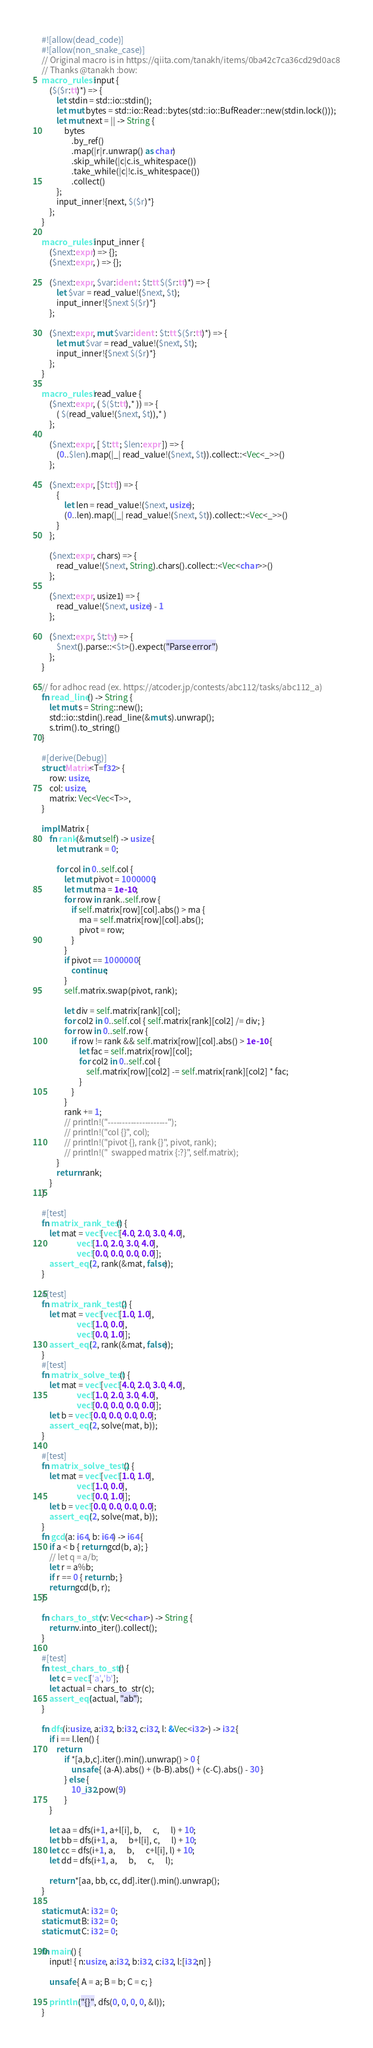Convert code to text. <code><loc_0><loc_0><loc_500><loc_500><_Rust_>#![allow(dead_code)]
#![allow(non_snake_case)]
// Original macro is in https://qiita.com/tanakh/items/0ba42c7ca36cd29d0ac8
// Thanks @tanakh :bow:
macro_rules! input {
    ($($r:tt)*) => {
        let stdin = std::io::stdin();
        let mut bytes = std::io::Read::bytes(std::io::BufReader::new(stdin.lock()));
        let mut next = || -> String {
            bytes
                .by_ref()
                .map(|r|r.unwrap() as char)
                .skip_while(|c|c.is_whitespace())
                .take_while(|c|!c.is_whitespace())
                .collect()
        };
        input_inner!{next, $($r)*}
    };
}
 
macro_rules! input_inner {
    ($next:expr) => {};
    ($next:expr, ) => {};
 
    ($next:expr, $var:ident : $t:tt $($r:tt)*) => {
        let $var = read_value!($next, $t);
        input_inner!{$next $($r)*}
    };
    
    ($next:expr, mut $var:ident : $t:tt $($r:tt)*) => {
        let mut $var = read_value!($next, $t);
        input_inner!{$next $($r)*}
    };
}
 
macro_rules! read_value {
    ($next:expr, ( $($t:tt),* )) => {
        ( $(read_value!($next, $t)),* )
    };
 
    ($next:expr, [ $t:tt ; $len:expr ]) => {
        (0..$len).map(|_| read_value!($next, $t)).collect::<Vec<_>>()
    };

    ($next:expr, [$t:tt]) => {
        {
            let len = read_value!($next, usize);
            (0..len).map(|_| read_value!($next, $t)).collect::<Vec<_>>()
        }
    };
 
    ($next:expr, chars) => {
        read_value!($next, String).chars().collect::<Vec<char>>()
    };
 
    ($next:expr, usize1) => {
        read_value!($next, usize) - 1
    };
 
    ($next:expr, $t:ty) => {
        $next().parse::<$t>().expect("Parse error")
    };
}

// for adhoc read (ex. https://atcoder.jp/contests/abc112/tasks/abc112_a)
fn read_line() -> String {
    let mut s = String::new();
    std::io::stdin().read_line(&mut s).unwrap();
    s.trim().to_string()
}

#[derive(Debug)]
struct Matrix<T=f32> {
    row: usize,
    col: usize,
    matrix: Vec<Vec<T>>,
}

impl Matrix {
    fn rank(&mut self) -> usize {
        let mut rank = 0;

        for col in 0..self.col {
            let mut pivot = 1000000;
            let mut ma = 1e-10;
            for row in rank..self.row {
                if self.matrix[row][col].abs() > ma {
                    ma = self.matrix[row][col].abs();
                    pivot = row;
                }
            }
            if pivot == 1000000 {
                continue;
            }
            self.matrix.swap(pivot, rank);

            let div = self.matrix[rank][col];
            for col2 in 0..self.col { self.matrix[rank][col2] /= div; }
            for row in 0..self.row {
                if row != rank && self.matrix[row][col].abs() > 1e-10 {
                    let fac = self.matrix[row][col];
                    for col2 in 0..self.col {
                        self.matrix[row][col2] -= self.matrix[rank][col2] * fac;
                    }
                }
            }
            rank += 1;
            // println!("---------------------");
            // println!("col {}", col);
            // println!("pivot {}, rank {}", pivot, rank);
            // println!("  swapped matrix {:?}", self.matrix);
        }
        return rank;
    }
}

#[test]
fn matrix_rank_test() {
    let mat = vec![vec![4.0, 2.0, 3.0, 4.0],
                   vec![1.0, 2.0, 3.0, 4.0],
                   vec![0.0, 0.0, 0.0, 0.0]];
    assert_eq!(2, rank(&mat, false));
}

#[test]
fn matrix_rank_test2() {
    let mat = vec![vec![1.0, 1.0],
                   vec![1.0, 0.0],
                   vec![0.0, 1.0]];
    assert_eq!(2, rank(&mat, false));
}
#[test]
fn matrix_solve_test() {
    let mat = vec![vec![4.0, 2.0, 3.0, 4.0],
                   vec![1.0, 2.0, 3.0, 4.0],
                   vec![0.0, 0.0, 0.0, 0.0]];
    let b = vec![0.0, 0.0, 0.0, 0.0];
    assert_eq!(2, solve(mat, b));
}

#[test]
fn matrix_solve_test2() {
    let mat = vec![vec![1.0, 1.0],
                   vec![1.0, 0.0],
                   vec![0.0, 1.0]];
    let b = vec![0.0, 0.0, 0.0, 0.0];
    assert_eq!(2, solve(mat, b));
}
fn gcd(a: i64, b: i64) -> i64 {
    if a < b { return gcd(b, a); }
    // let q = a/b;
    let r = a%b;
    if r == 0 { return b; }
    return gcd(b, r);
}

fn chars_to_str(v: Vec<char>) -> String {
    return v.into_iter().collect();
}

#[test]
fn test_chars_to_str() {
    let c = vec!['a','b'];
    let actual = chars_to_str(c);
    assert_eq!(actual, "ab");
}

fn dfs(i:usize, a:i32, b:i32, c:i32, l: &Vec<i32>) -> i32 {
    if i == l.len() {
        return
            if *[a,b,c].iter().min().unwrap() > 0 {
                unsafe { (a-A).abs() + (b-B).abs() + (c-C).abs() - 30 }
            } else {
                10_i32.pow(9)
            }
    }

    let aa = dfs(i+1, a+l[i], b,      c,      l) + 10;
    let bb = dfs(i+1, a,      b+l[i], c,      l) + 10;
    let cc = dfs(i+1, a,      b,      c+l[i], l) + 10;
    let dd = dfs(i+1, a,      b,      c,      l);

    return *[aa, bb, cc, dd].iter().min().unwrap();
}

static mut A: i32 = 0;
static mut B: i32 = 0;
static mut C: i32 = 0;

fn main() {
    input! { n:usize, a:i32, b:i32, c:i32, l:[i32;n] }

    unsafe { A = a; B = b; C = c; }

    println!("{}", dfs(0, 0, 0, 0, &l));
}
</code> 